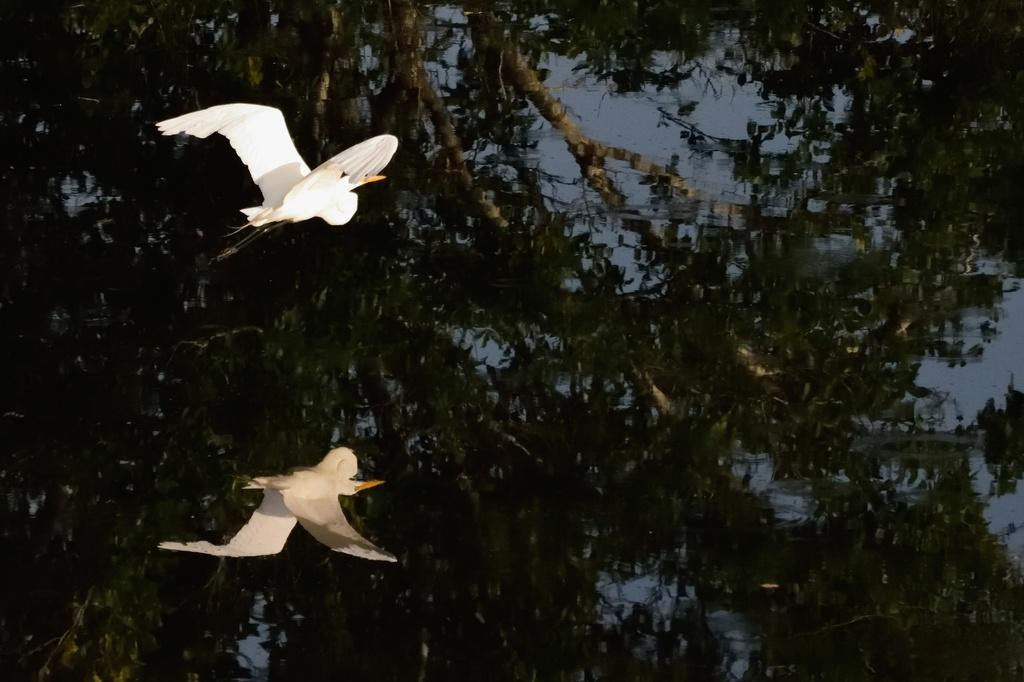What is the main subject of the image? The main subject of the image is a bird flying. What can be seen in the background of the image? There is water visible in the image, and there is a reflection of a tree and the bird on the water. What type of powder is being used by the lawyer in the image? There is no lawyer or powder present in the image; it features a bird flying over water with reflections of a tree and the bird. 